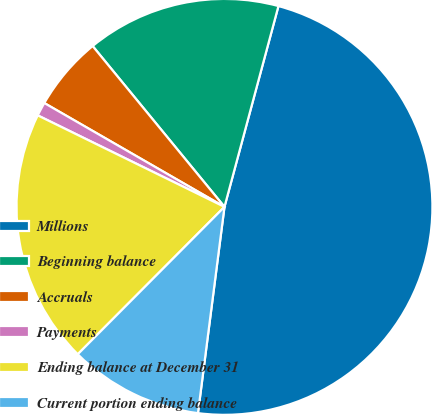Convert chart. <chart><loc_0><loc_0><loc_500><loc_500><pie_chart><fcel>Millions<fcel>Beginning balance<fcel>Accruals<fcel>Payments<fcel>Ending balance at December 31<fcel>Current portion ending balance<nl><fcel>47.86%<fcel>15.11%<fcel>5.75%<fcel>1.07%<fcel>19.79%<fcel>10.43%<nl></chart> 